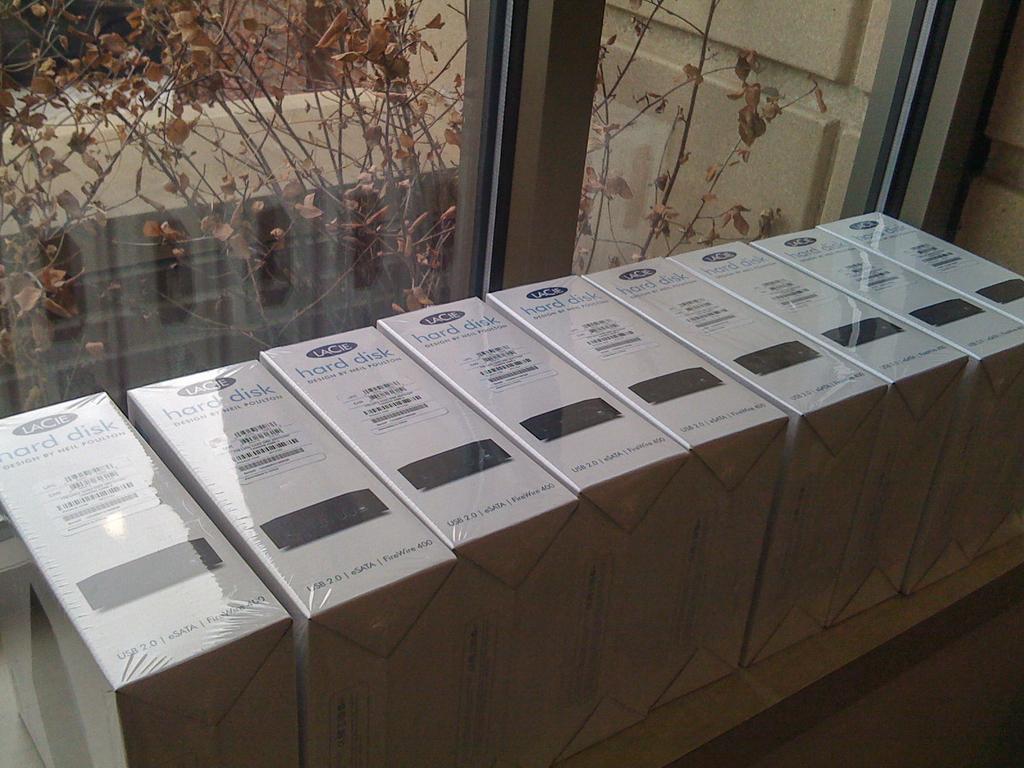Describe this image in one or two sentences. In the center of the image, we can see some boxes and in the background, there is a window and through the window we can see a tree with leaves. 